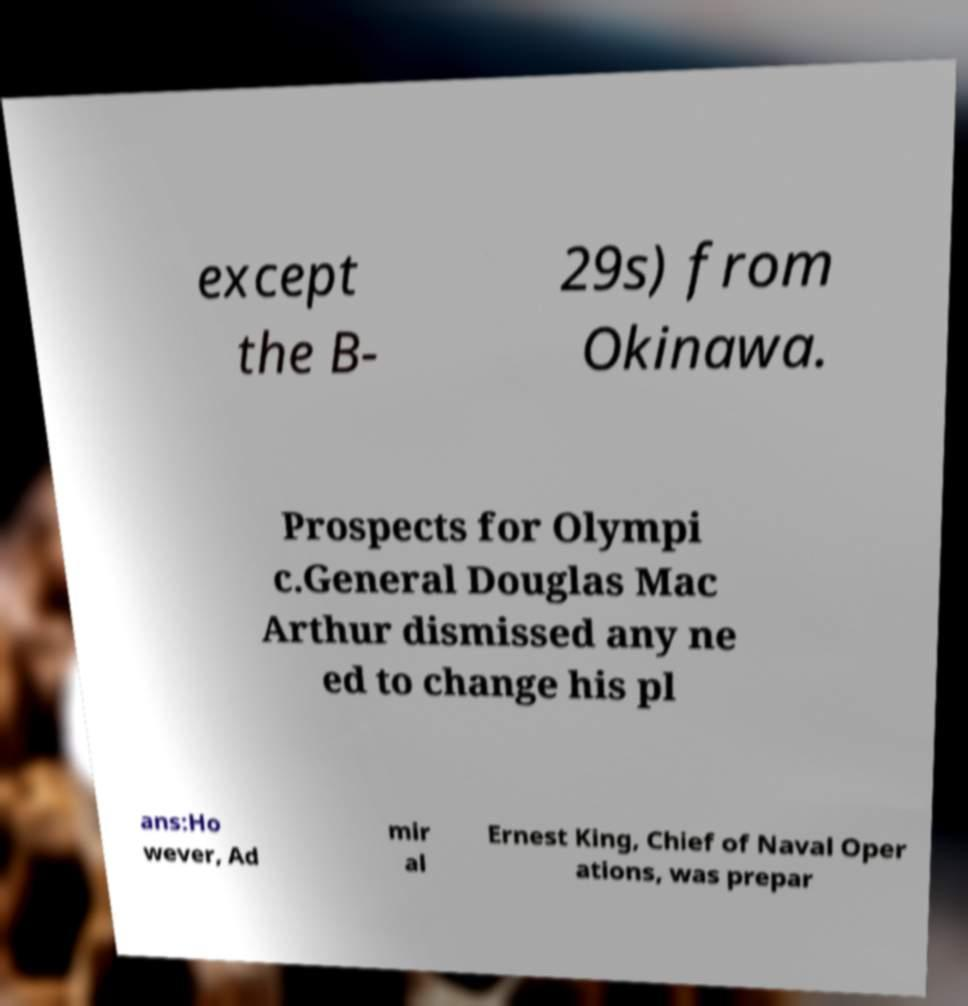Could you extract and type out the text from this image? except the B- 29s) from Okinawa. Prospects for Olympi c.General Douglas Mac Arthur dismissed any ne ed to change his pl ans:Ho wever, Ad mir al Ernest King, Chief of Naval Oper ations, was prepar 